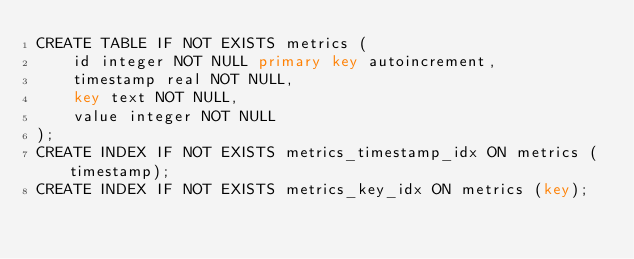<code> <loc_0><loc_0><loc_500><loc_500><_SQL_>CREATE TABLE IF NOT EXISTS metrics (
    id integer NOT NULL primary key autoincrement,
    timestamp real NOT NULL,
    key text NOT NULL,
    value integer NOT NULL
);
CREATE INDEX IF NOT EXISTS metrics_timestamp_idx ON metrics (timestamp);
CREATE INDEX IF NOT EXISTS metrics_key_idx ON metrics (key);
</code> 